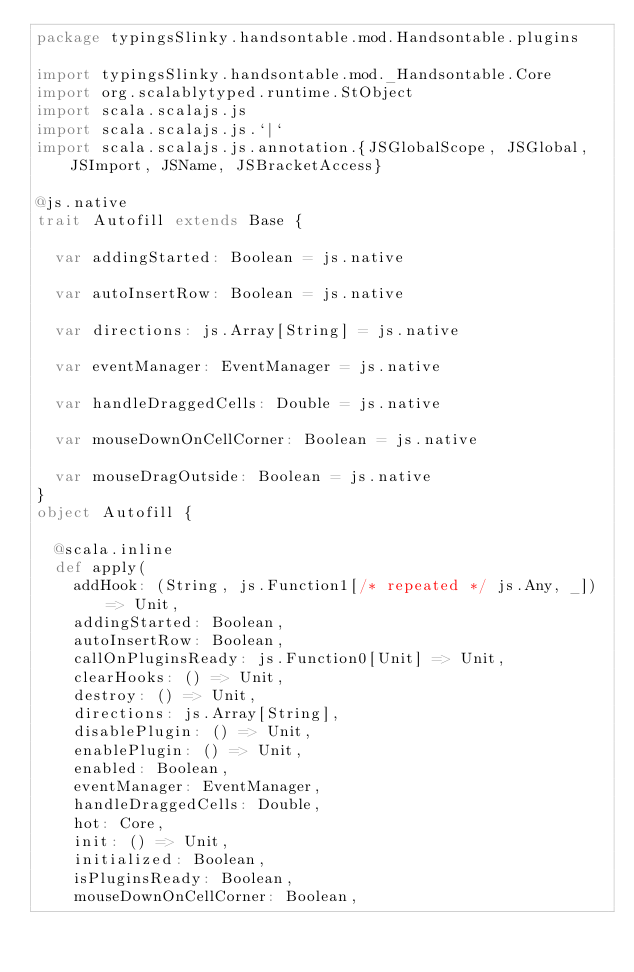<code> <loc_0><loc_0><loc_500><loc_500><_Scala_>package typingsSlinky.handsontable.mod.Handsontable.plugins

import typingsSlinky.handsontable.mod._Handsontable.Core
import org.scalablytyped.runtime.StObject
import scala.scalajs.js
import scala.scalajs.js.`|`
import scala.scalajs.js.annotation.{JSGlobalScope, JSGlobal, JSImport, JSName, JSBracketAccess}

@js.native
trait Autofill extends Base {
  
  var addingStarted: Boolean = js.native
  
  var autoInsertRow: Boolean = js.native
  
  var directions: js.Array[String] = js.native
  
  var eventManager: EventManager = js.native
  
  var handleDraggedCells: Double = js.native
  
  var mouseDownOnCellCorner: Boolean = js.native
  
  var mouseDragOutside: Boolean = js.native
}
object Autofill {
  
  @scala.inline
  def apply(
    addHook: (String, js.Function1[/* repeated */ js.Any, _]) => Unit,
    addingStarted: Boolean,
    autoInsertRow: Boolean,
    callOnPluginsReady: js.Function0[Unit] => Unit,
    clearHooks: () => Unit,
    destroy: () => Unit,
    directions: js.Array[String],
    disablePlugin: () => Unit,
    enablePlugin: () => Unit,
    enabled: Boolean,
    eventManager: EventManager,
    handleDraggedCells: Double,
    hot: Core,
    init: () => Unit,
    initialized: Boolean,
    isPluginsReady: Boolean,
    mouseDownOnCellCorner: Boolean,</code> 